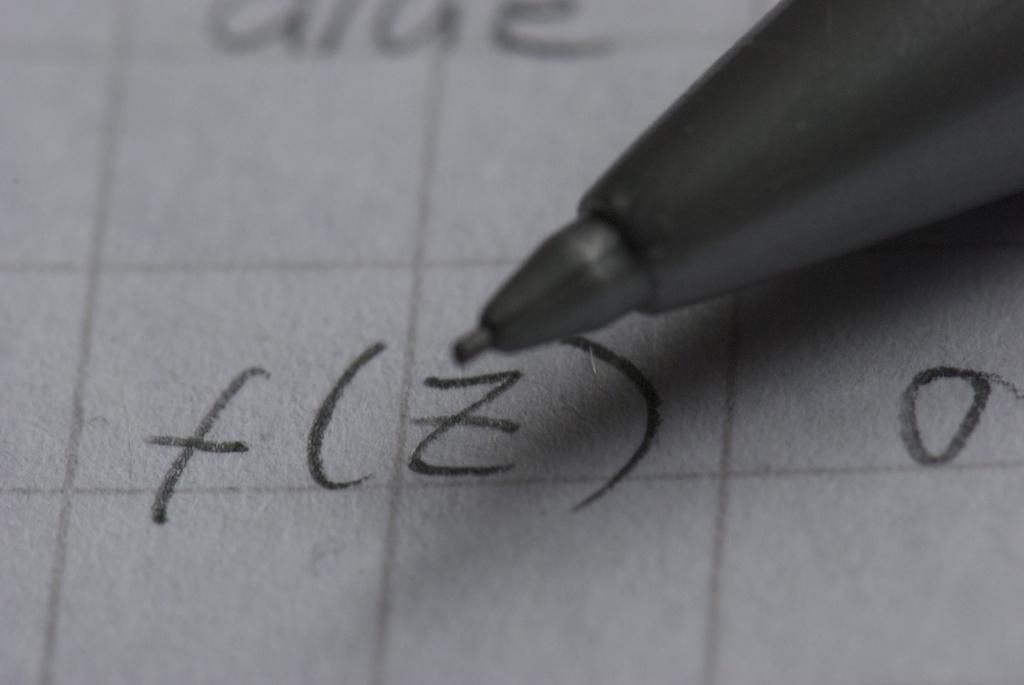How would you summarize this image in a sentence or two? In this image we can see a click pencil. And we can see text on a surface. 